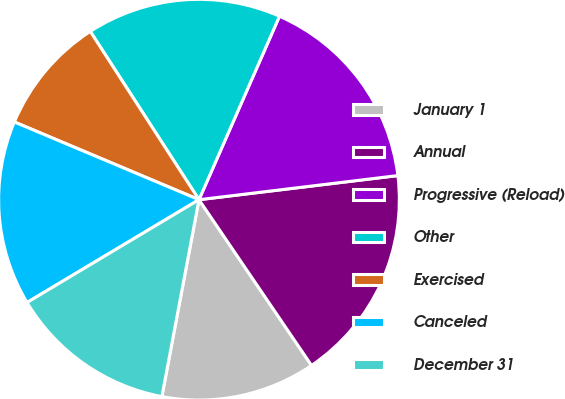Convert chart. <chart><loc_0><loc_0><loc_500><loc_500><pie_chart><fcel>January 1<fcel>Annual<fcel>Progressive (Reload)<fcel>Other<fcel>Exercised<fcel>Canceled<fcel>December 31<nl><fcel>12.46%<fcel>17.43%<fcel>16.5%<fcel>15.71%<fcel>9.53%<fcel>14.92%<fcel>13.46%<nl></chart> 